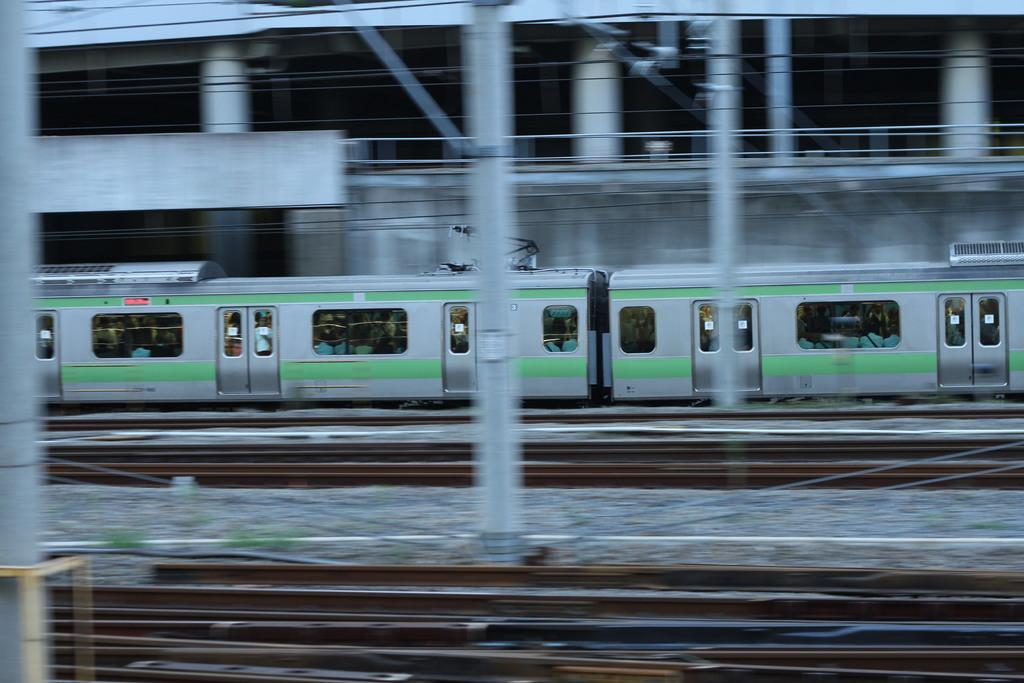How would you summarize this image in a sentence or two? In this image, there are groups of people in a train, which is on the railway track. There are poles and wires. In the background, I can see a building with pillars. 